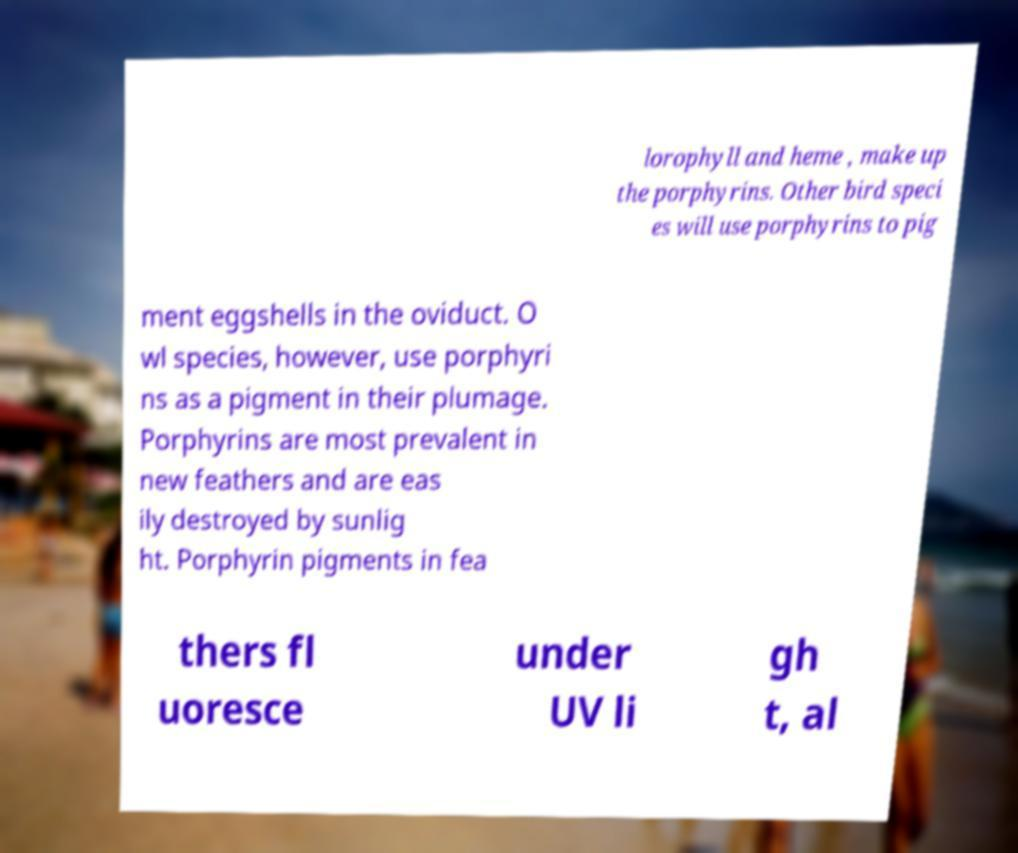What messages or text are displayed in this image? I need them in a readable, typed format. lorophyll and heme , make up the porphyrins. Other bird speci es will use porphyrins to pig ment eggshells in the oviduct. O wl species, however, use porphyri ns as a pigment in their plumage. Porphyrins are most prevalent in new feathers and are eas ily destroyed by sunlig ht. Porphyrin pigments in fea thers fl uoresce under UV li gh t, al 